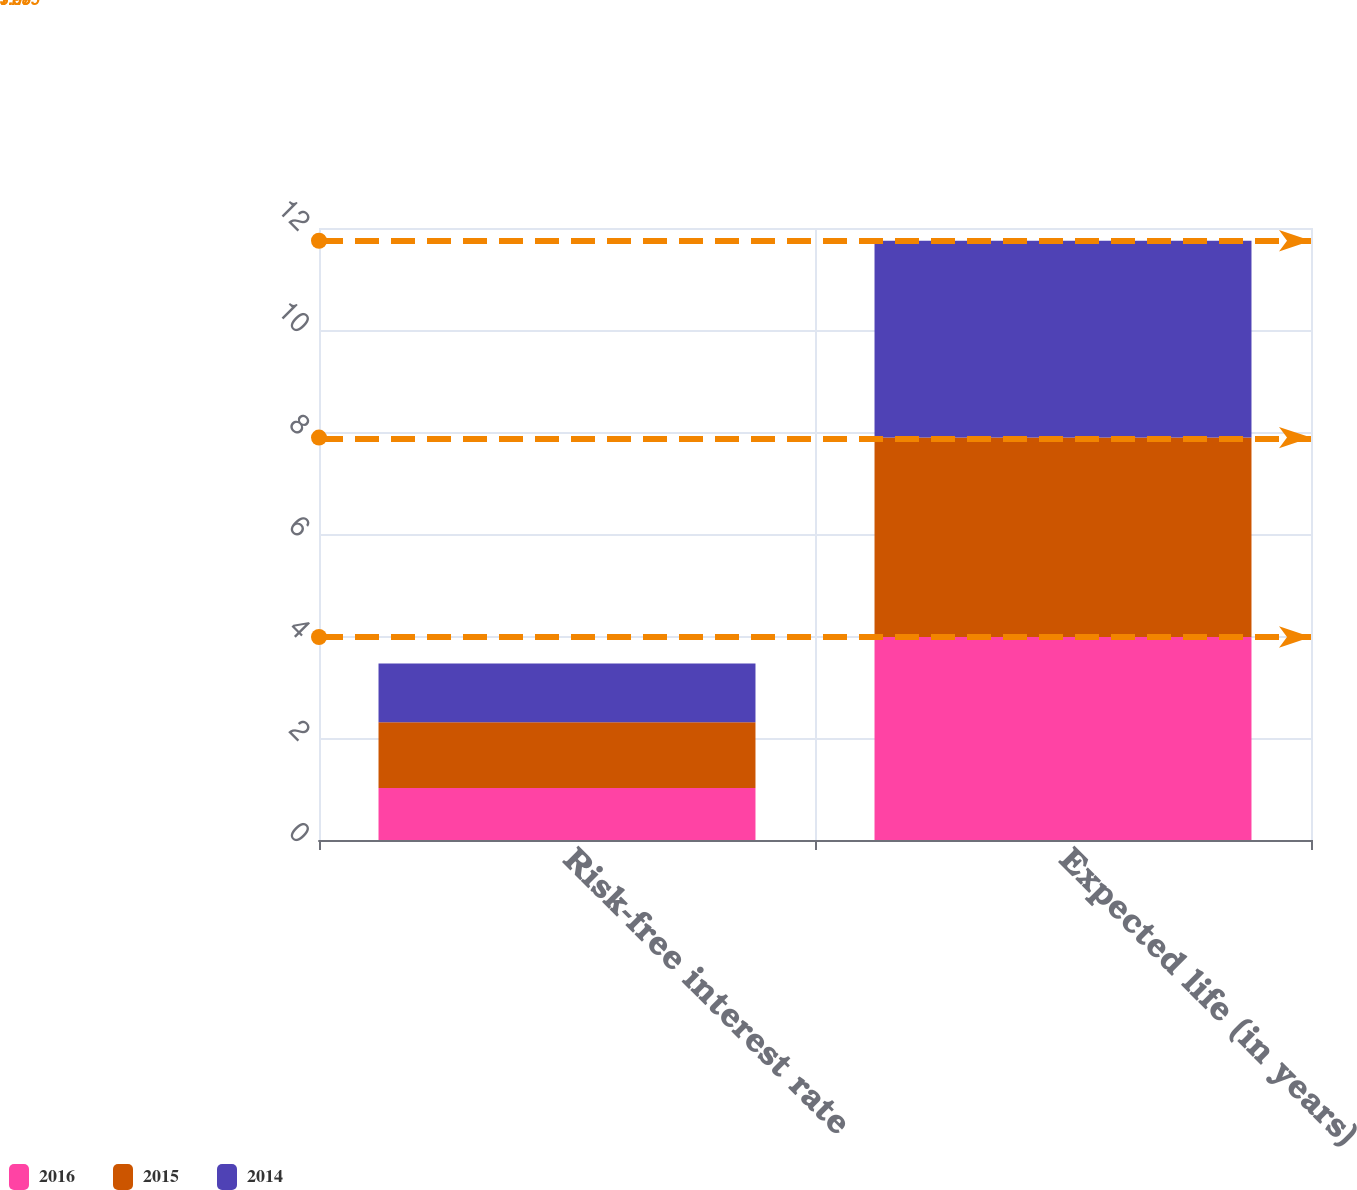<chart> <loc_0><loc_0><loc_500><loc_500><stacked_bar_chart><ecel><fcel>Risk-free interest rate<fcel>Expected life (in years)<nl><fcel>2016<fcel>1.02<fcel>3.98<nl><fcel>2015<fcel>1.29<fcel>3.91<nl><fcel>2014<fcel>1.15<fcel>3.86<nl></chart> 